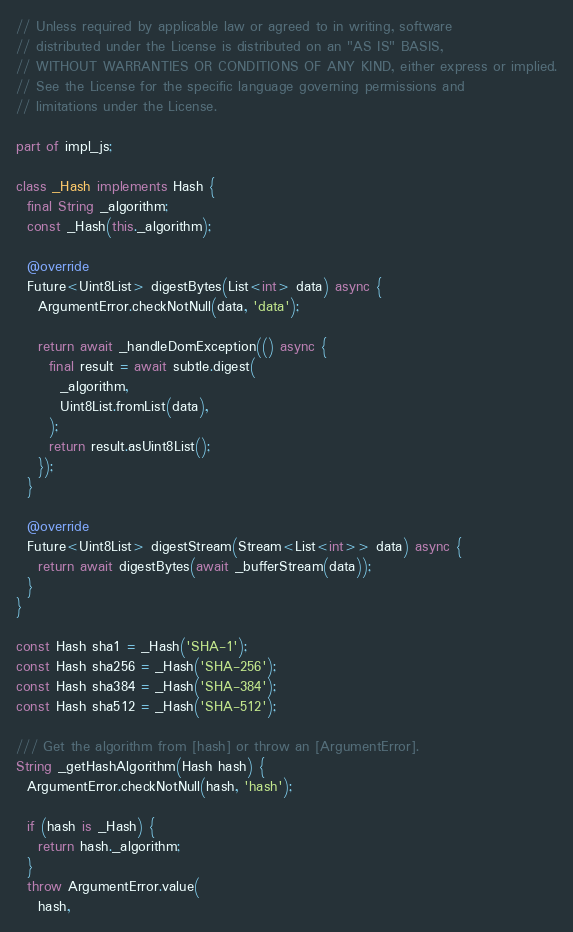Convert code to text. <code><loc_0><loc_0><loc_500><loc_500><_Dart_>// Unless required by applicable law or agreed to in writing, software
// distributed under the License is distributed on an "AS IS" BASIS,
// WITHOUT WARRANTIES OR CONDITIONS OF ANY KIND, either express or implied.
// See the License for the specific language governing permissions and
// limitations under the License.

part of impl_js;

class _Hash implements Hash {
  final String _algorithm;
  const _Hash(this._algorithm);

  @override
  Future<Uint8List> digestBytes(List<int> data) async {
    ArgumentError.checkNotNull(data, 'data');

    return await _handleDomException(() async {
      final result = await subtle.digest(
        _algorithm,
        Uint8List.fromList(data),
      );
      return result.asUint8List();
    });
  }

  @override
  Future<Uint8List> digestStream(Stream<List<int>> data) async {
    return await digestBytes(await _bufferStream(data));
  }
}

const Hash sha1 = _Hash('SHA-1');
const Hash sha256 = _Hash('SHA-256');
const Hash sha384 = _Hash('SHA-384');
const Hash sha512 = _Hash('SHA-512');

/// Get the algorithm from [hash] or throw an [ArgumentError].
String _getHashAlgorithm(Hash hash) {
  ArgumentError.checkNotNull(hash, 'hash');

  if (hash is _Hash) {
    return hash._algorithm;
  }
  throw ArgumentError.value(
    hash,</code> 